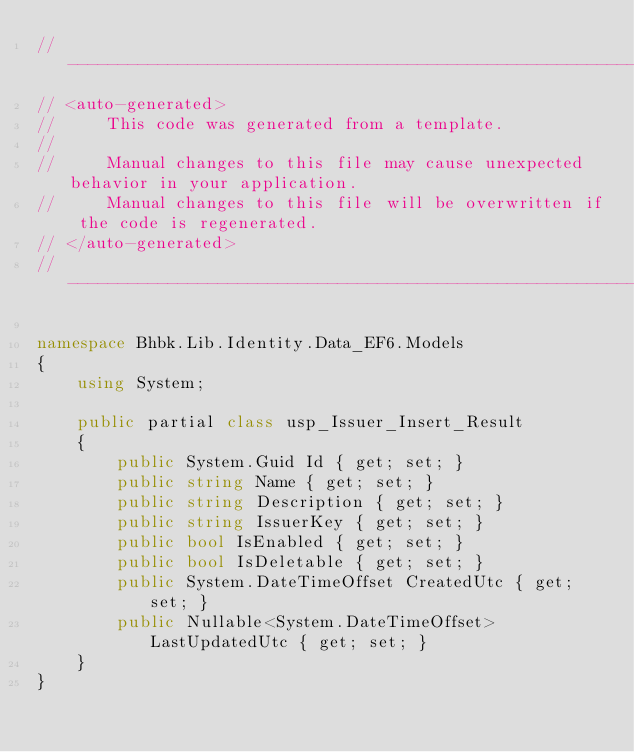Convert code to text. <code><loc_0><loc_0><loc_500><loc_500><_C#_>//------------------------------------------------------------------------------
// <auto-generated>
//     This code was generated from a template.
//
//     Manual changes to this file may cause unexpected behavior in your application.
//     Manual changes to this file will be overwritten if the code is regenerated.
// </auto-generated>
//------------------------------------------------------------------------------

namespace Bhbk.Lib.Identity.Data_EF6.Models
{
    using System;
    
    public partial class usp_Issuer_Insert_Result
    {
        public System.Guid Id { get; set; }
        public string Name { get; set; }
        public string Description { get; set; }
        public string IssuerKey { get; set; }
        public bool IsEnabled { get; set; }
        public bool IsDeletable { get; set; }
        public System.DateTimeOffset CreatedUtc { get; set; }
        public Nullable<System.DateTimeOffset> LastUpdatedUtc { get; set; }
    }
}
</code> 